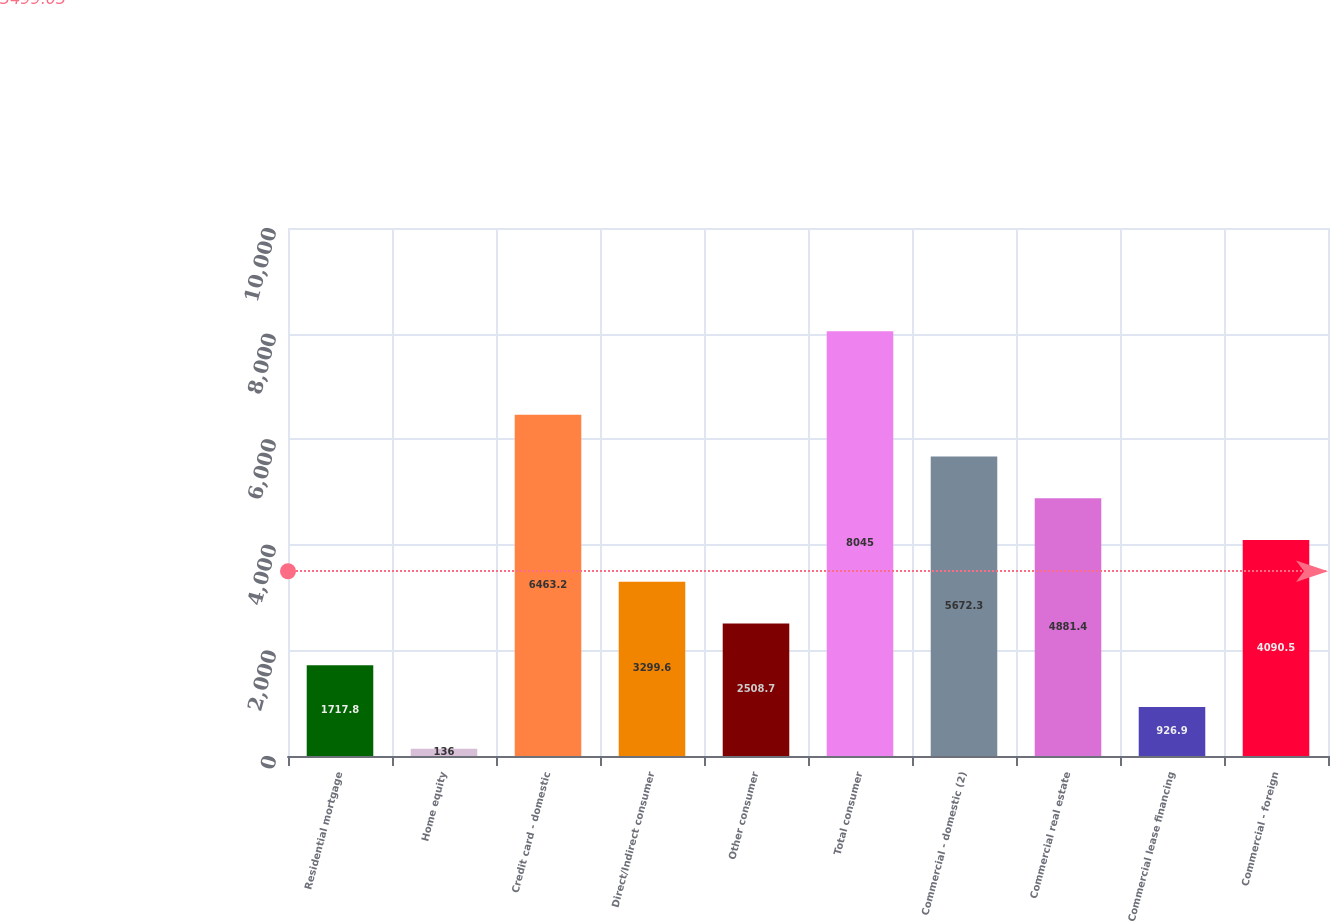Convert chart to OTSL. <chart><loc_0><loc_0><loc_500><loc_500><bar_chart><fcel>Residential mortgage<fcel>Home equity<fcel>Credit card - domestic<fcel>Direct/Indirect consumer<fcel>Other consumer<fcel>Total consumer<fcel>Commercial - domestic (2)<fcel>Commercial real estate<fcel>Commercial lease financing<fcel>Commercial - foreign<nl><fcel>1717.8<fcel>136<fcel>6463.2<fcel>3299.6<fcel>2508.7<fcel>8045<fcel>5672.3<fcel>4881.4<fcel>926.9<fcel>4090.5<nl></chart> 